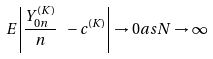Convert formula to latex. <formula><loc_0><loc_0><loc_500><loc_500>E \left | \frac { Y ^ { ( K ) } _ { 0 n } } { n } \ - c ^ { ( K ) } \right | \to 0 a s N \to \infty</formula> 